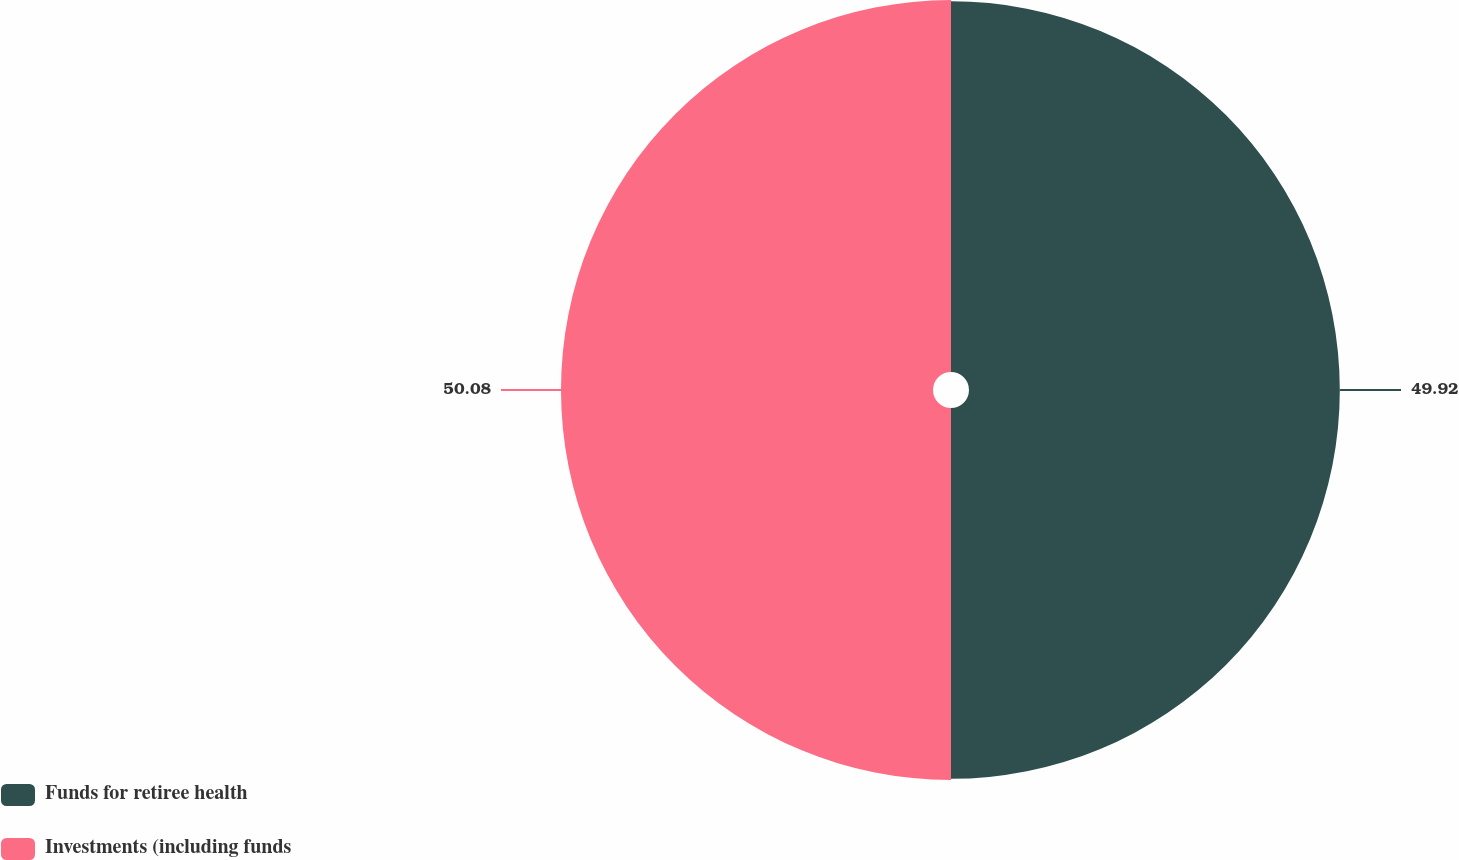Convert chart to OTSL. <chart><loc_0><loc_0><loc_500><loc_500><pie_chart><fcel>Funds for retiree health<fcel>Investments (including funds<nl><fcel>49.92%<fcel>50.08%<nl></chart> 